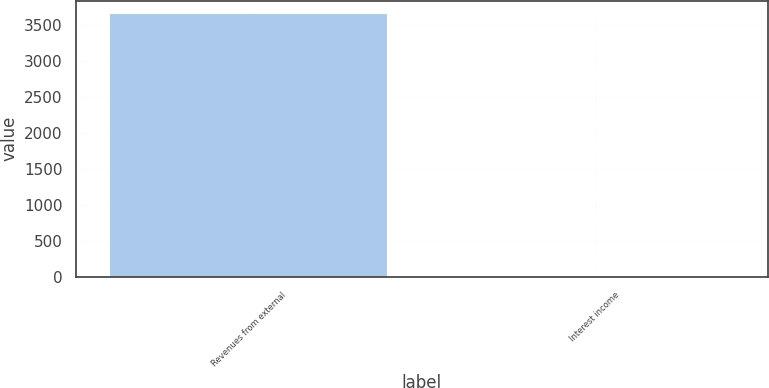<chart> <loc_0><loc_0><loc_500><loc_500><bar_chart><fcel>Revenues from external<fcel>Interest income<nl><fcel>3659<fcel>2<nl></chart> 